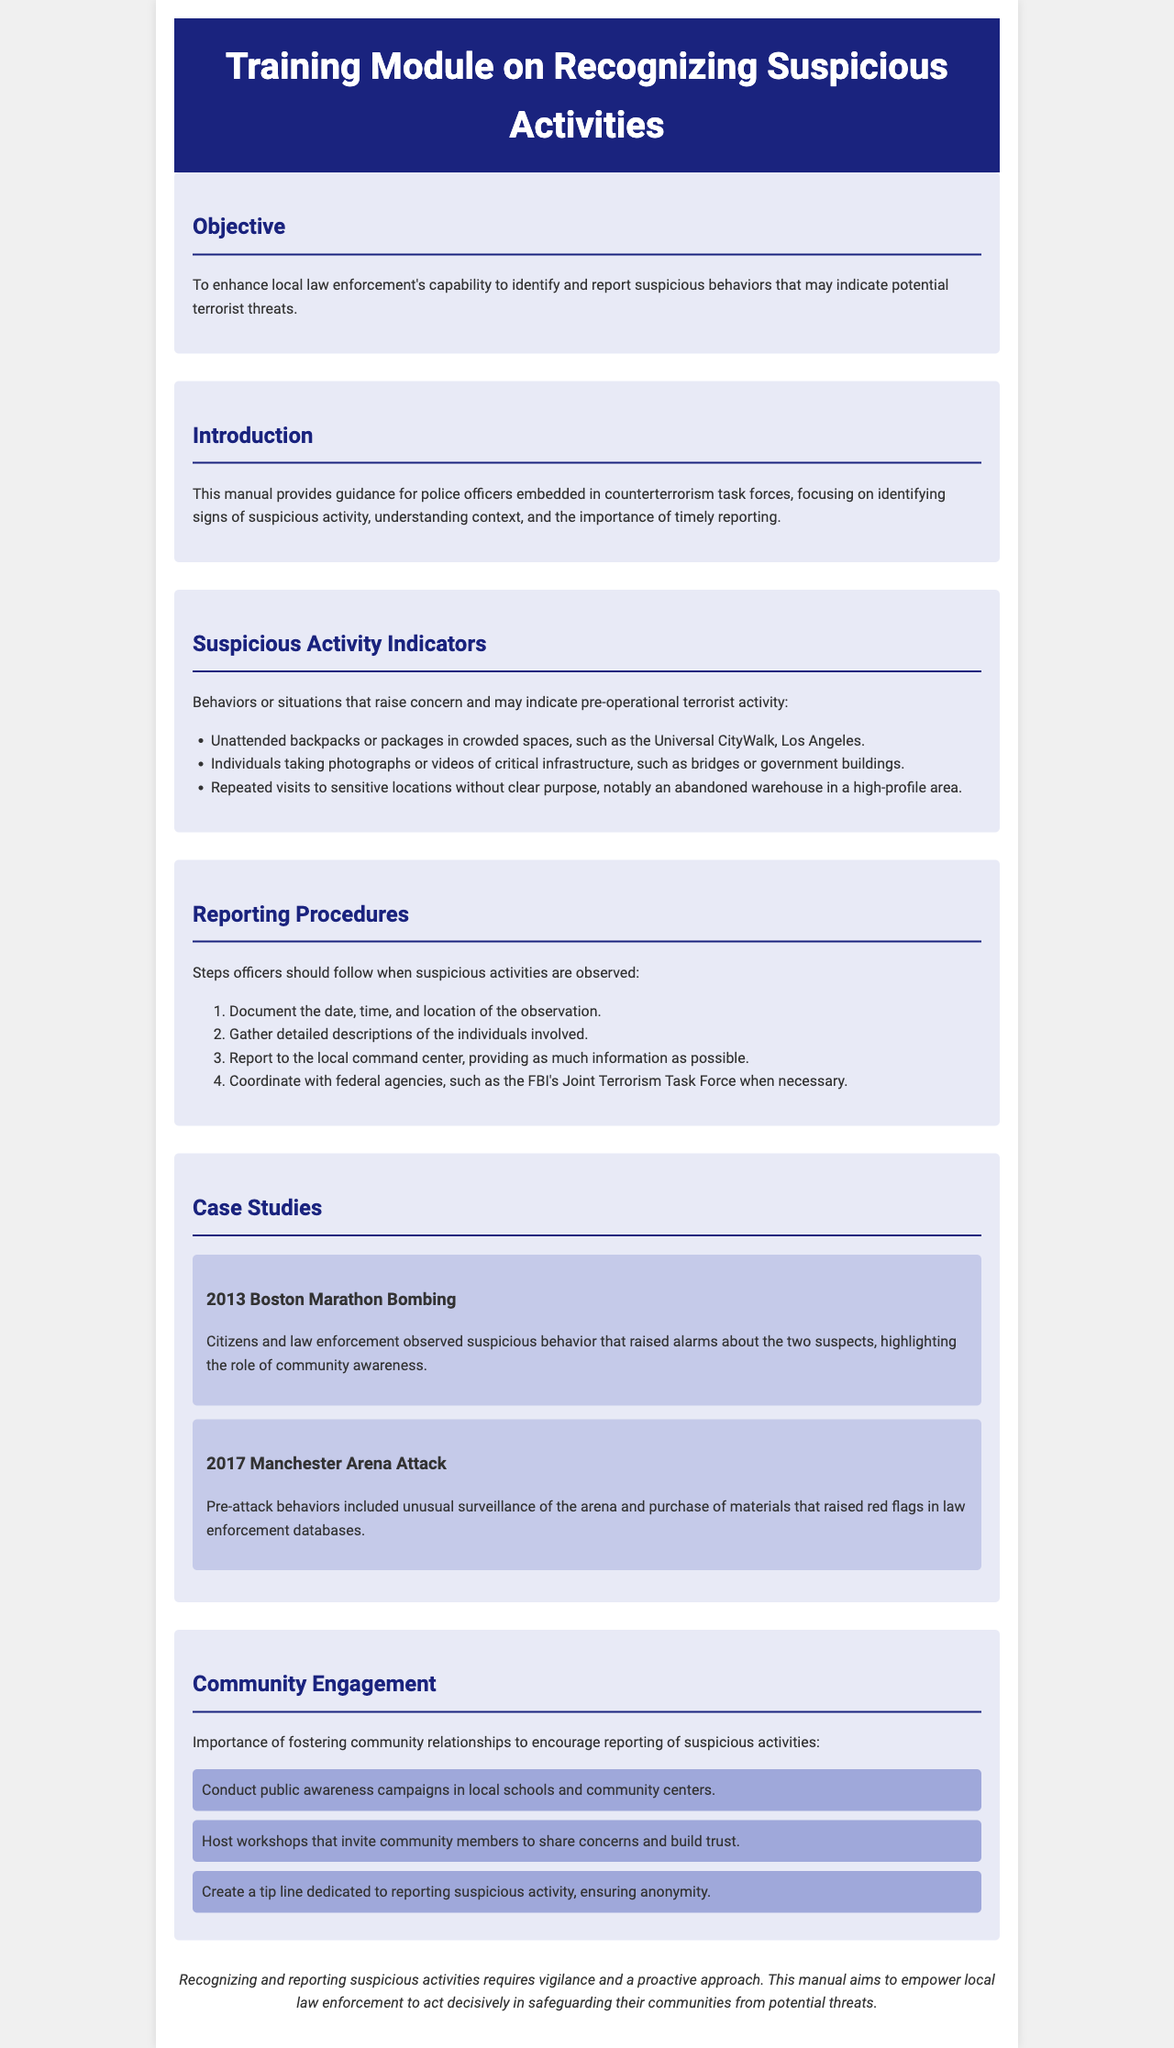what is the title of the manual? The title of the manual is stated in the header section of the document.
Answer: Training Module on Recognizing Suspicious Activities what is the main objective of the training module? The objective is outlined in the first section of the document.
Answer: To enhance local law enforcement's capability to identify and report suspicious behaviors that may indicate potential terrorist threats list one suspicious activity indicator. The document provides several examples of suspicious activity indicators in its indicators section.
Answer: Unattended backpacks or packages in crowded spaces how many steps are outlined in the reporting procedures? The reporting procedures section includes a numbered list of steps for officers to follow.
Answer: Four name one case study mentioned in the manual. The case studies section highlights significant events related to suspicious activities.
Answer: 2013 Boston Marathon Bombing what is one community engagement strategy mentioned? The strategies for community engagement are listed in their own section of the document.
Answer: Conduct public awareness campaigns in local schools and community centers why is community engagement important according to the manual? The importance of community engagement is discussed in the community engagement section of the document.
Answer: To encourage reporting of suspicious activities which federal agency is mentioned for coordination? The manual specifies cooperation with a federal agency in the reporting procedures section.
Answer: FBI's Joint Terrorism Task Force 